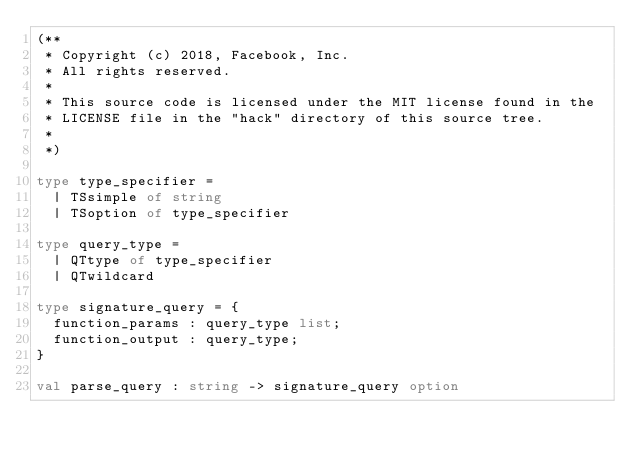Convert code to text. <code><loc_0><loc_0><loc_500><loc_500><_OCaml_>(**
 * Copyright (c) 2018, Facebook, Inc.
 * All rights reserved.
 *
 * This source code is licensed under the MIT license found in the
 * LICENSE file in the "hack" directory of this source tree.
 *
 *)

type type_specifier =
  | TSsimple of string
  | TSoption of type_specifier

type query_type =
  | QTtype of type_specifier
  | QTwildcard

type signature_query = {
  function_params : query_type list;
  function_output : query_type;
}

val parse_query : string -> signature_query option
</code> 